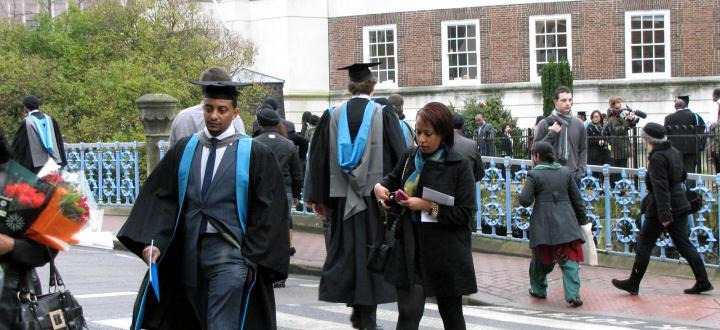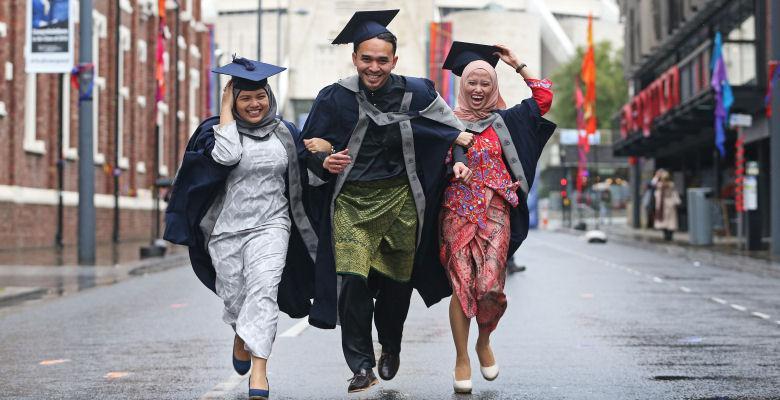The first image is the image on the left, the second image is the image on the right. Given the left and right images, does the statement "There is exactly three graduation students in the right image." hold true? Answer yes or no. Yes. The first image is the image on the left, the second image is the image on the right. Evaluate the accuracy of this statement regarding the images: "An image shows exactly one male and one female graduate, wearing matching robes.". Is it true? Answer yes or no. No. 